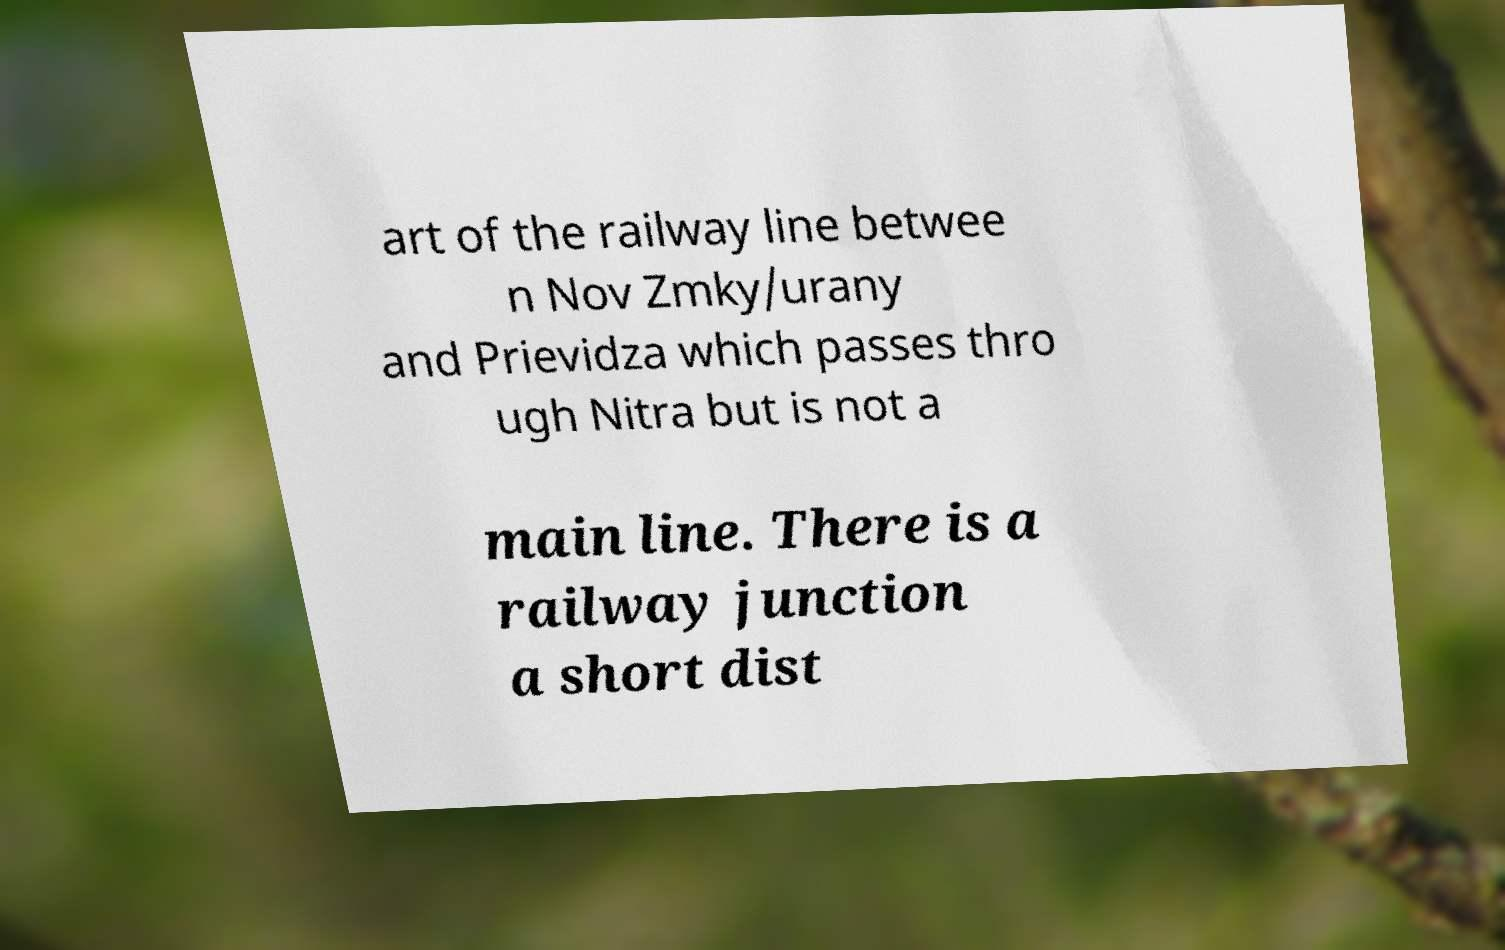Please identify and transcribe the text found in this image. art of the railway line betwee n Nov Zmky/urany and Prievidza which passes thro ugh Nitra but is not a main line. There is a railway junction a short dist 